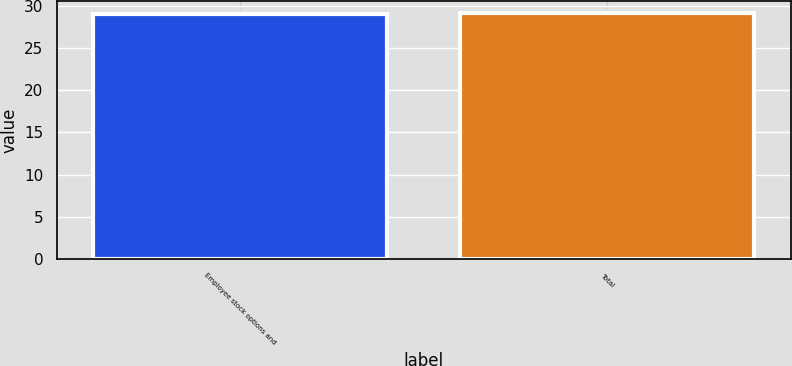Convert chart. <chart><loc_0><loc_0><loc_500><loc_500><bar_chart><fcel>Employee stock options and<fcel>Total<nl><fcel>29<fcel>29.1<nl></chart> 